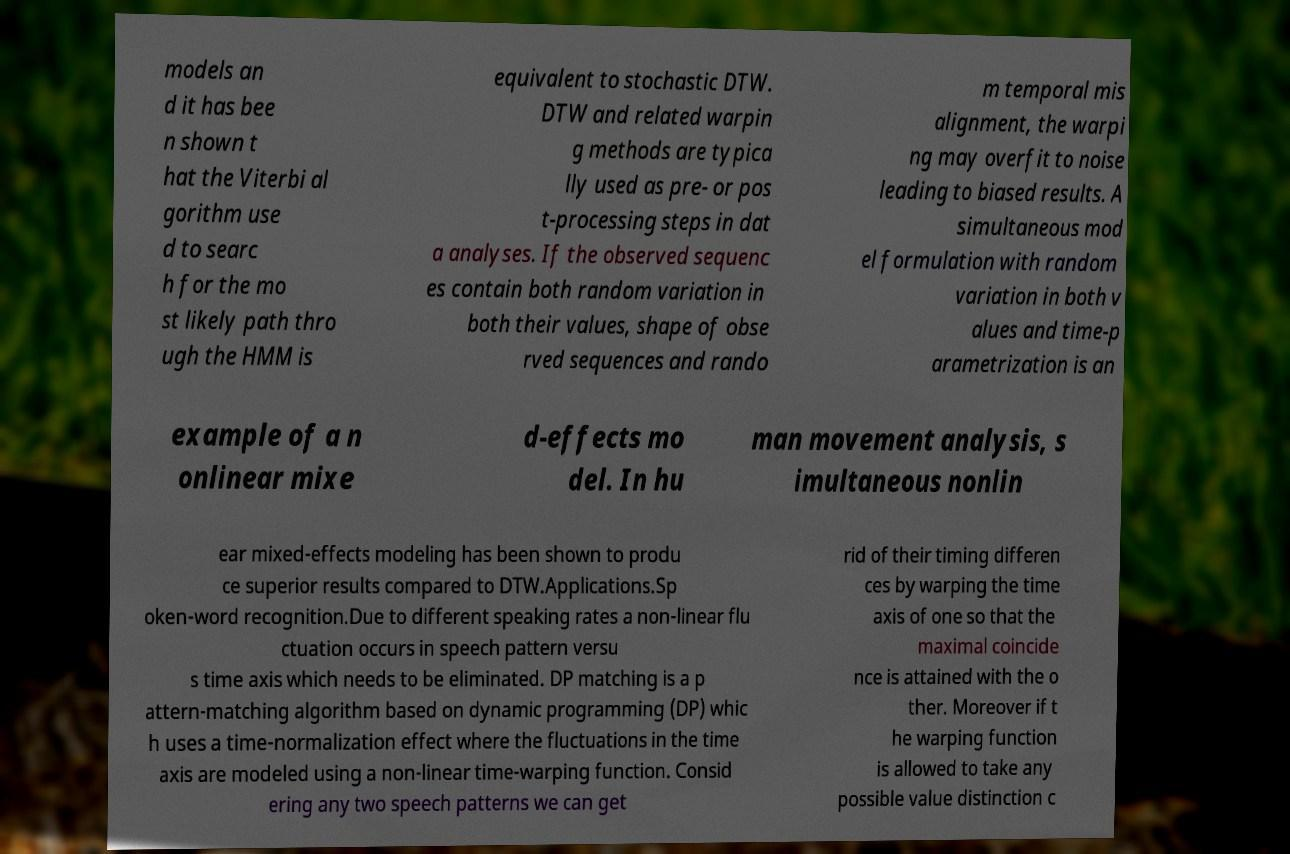Please read and relay the text visible in this image. What does it say? models an d it has bee n shown t hat the Viterbi al gorithm use d to searc h for the mo st likely path thro ugh the HMM is equivalent to stochastic DTW. DTW and related warpin g methods are typica lly used as pre- or pos t-processing steps in dat a analyses. If the observed sequenc es contain both random variation in both their values, shape of obse rved sequences and rando m temporal mis alignment, the warpi ng may overfit to noise leading to biased results. A simultaneous mod el formulation with random variation in both v alues and time-p arametrization is an example of a n onlinear mixe d-effects mo del. In hu man movement analysis, s imultaneous nonlin ear mixed-effects modeling has been shown to produ ce superior results compared to DTW.Applications.Sp oken-word recognition.Due to different speaking rates a non-linear flu ctuation occurs in speech pattern versu s time axis which needs to be eliminated. DP matching is a p attern-matching algorithm based on dynamic programming (DP) whic h uses a time-normalization effect where the fluctuations in the time axis are modeled using a non-linear time-warping function. Consid ering any two speech patterns we can get rid of their timing differen ces by warping the time axis of one so that the maximal coincide nce is attained with the o ther. Moreover if t he warping function is allowed to take any possible value distinction c 